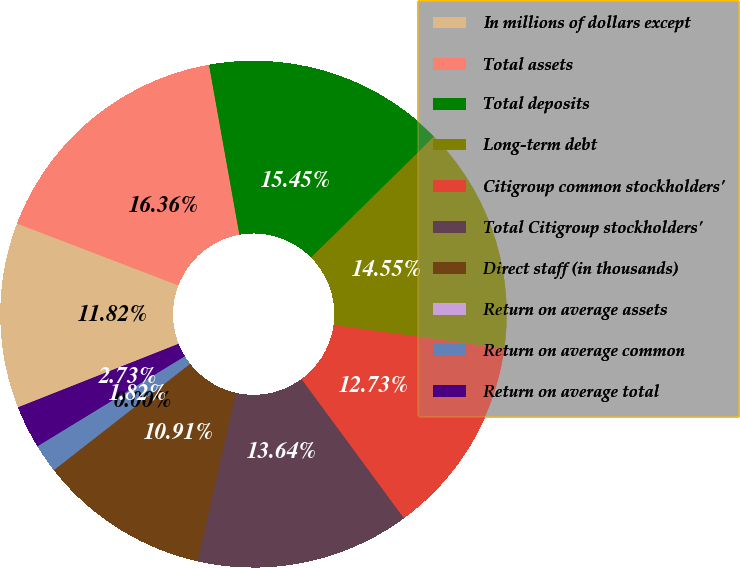<chart> <loc_0><loc_0><loc_500><loc_500><pie_chart><fcel>In millions of dollars except<fcel>Total assets<fcel>Total deposits<fcel>Long-term debt<fcel>Citigroup common stockholders'<fcel>Total Citigroup stockholders'<fcel>Direct staff (in thousands)<fcel>Return on average assets<fcel>Return on average common<fcel>Return on average total<nl><fcel>11.82%<fcel>16.36%<fcel>15.45%<fcel>14.55%<fcel>12.73%<fcel>13.64%<fcel>10.91%<fcel>0.0%<fcel>1.82%<fcel>2.73%<nl></chart> 